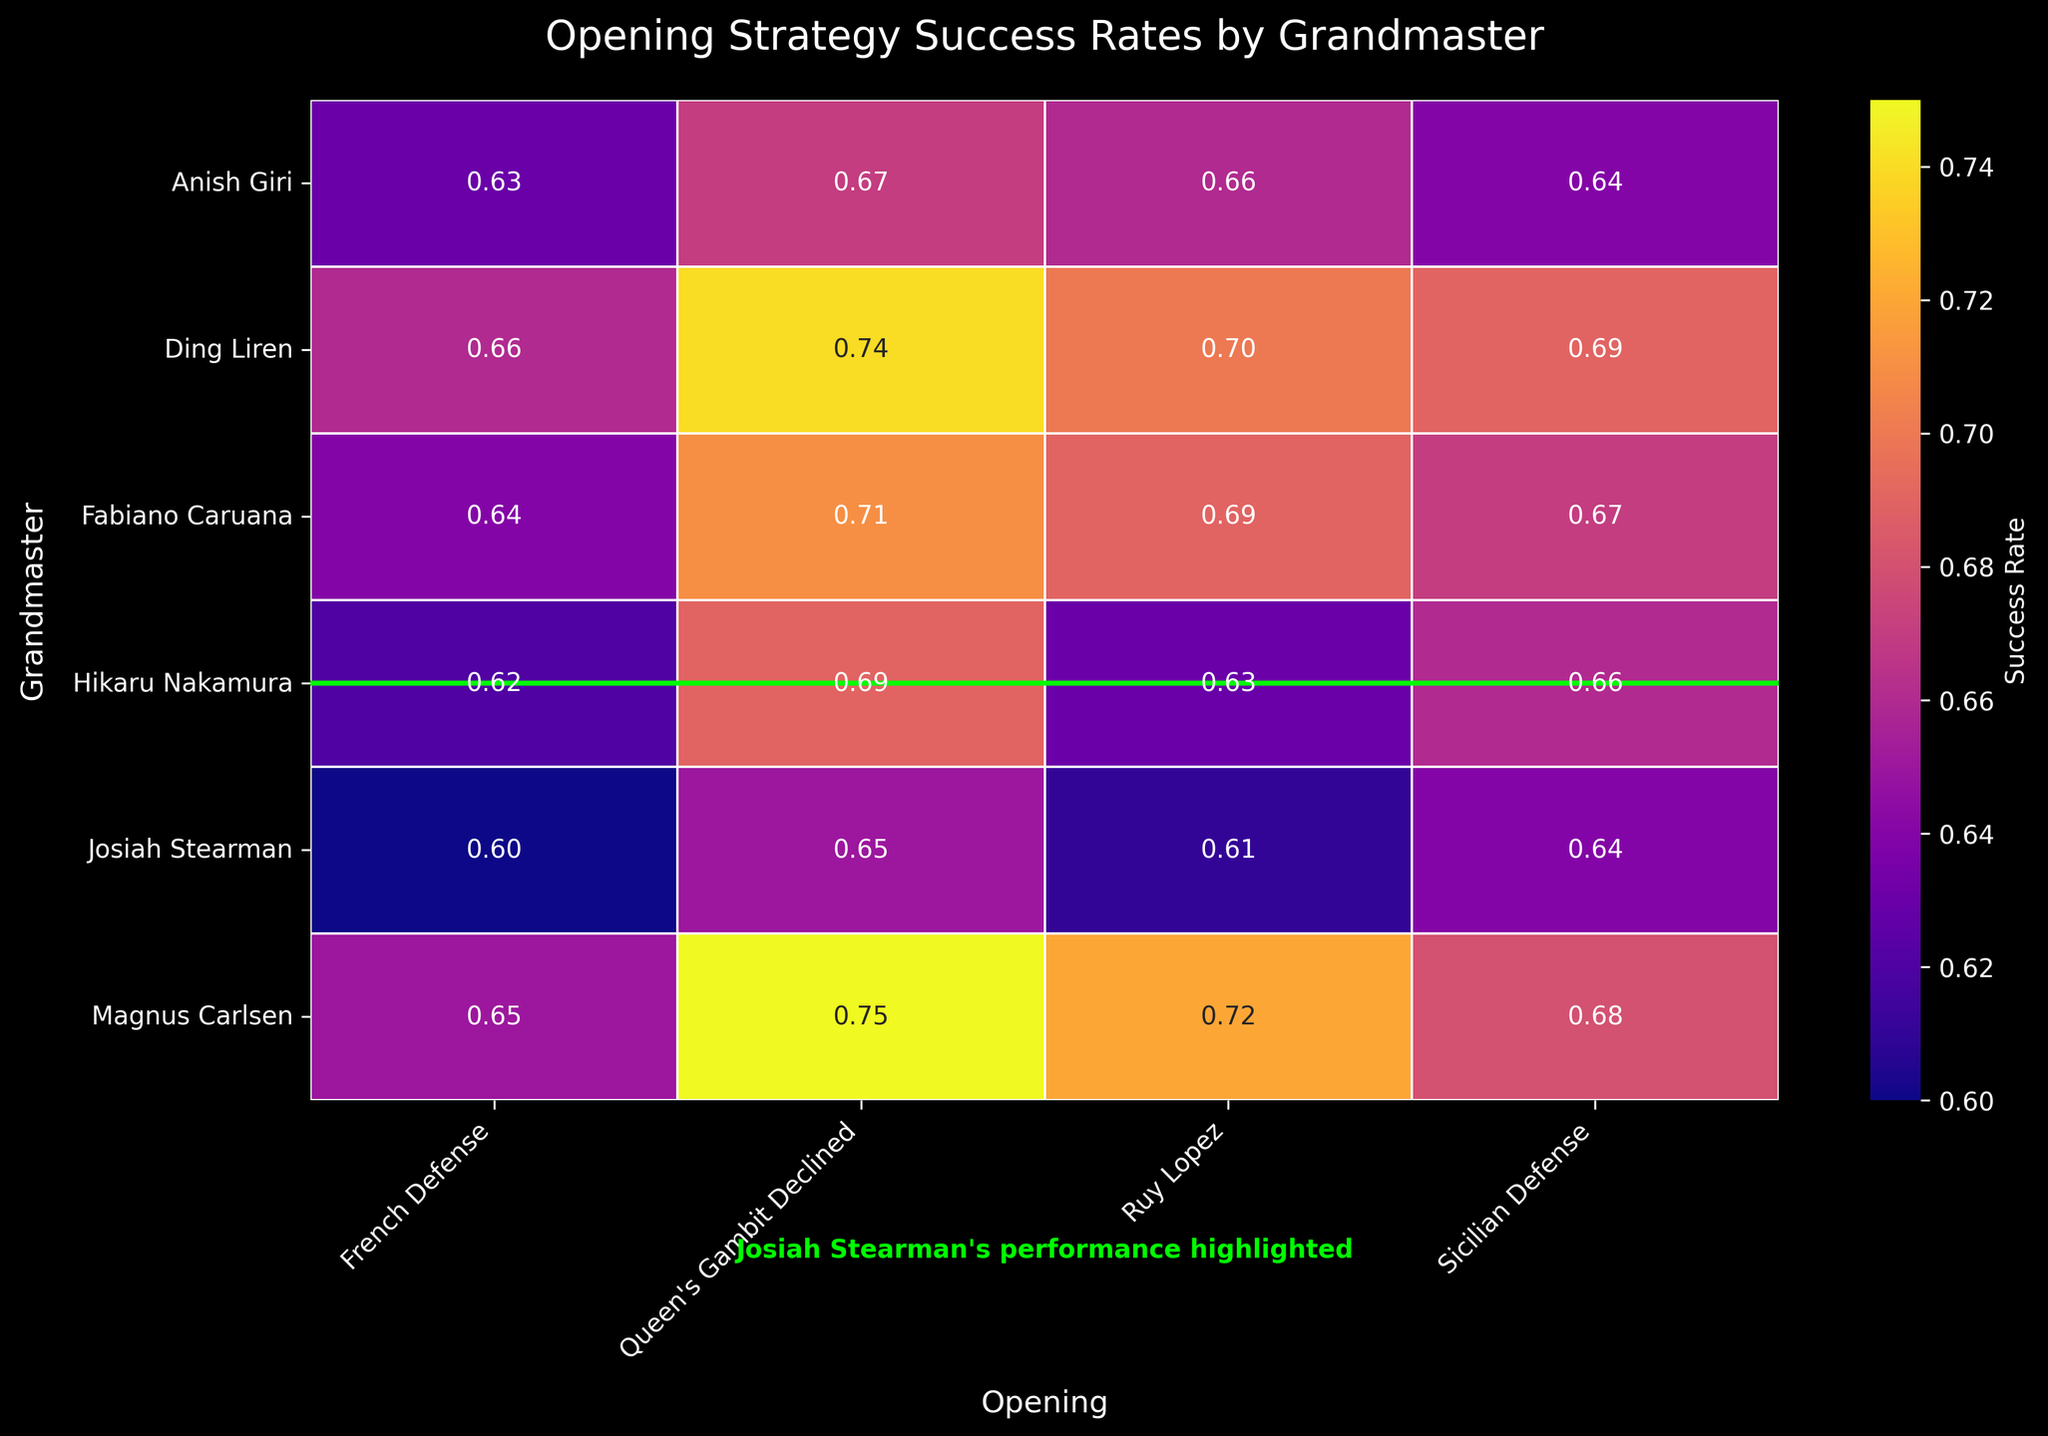What is the title of the heatmap? The title is usually displayed at the top of the plot. It is a descriptor for the figure and can be directly read from the top part of the figure.
Answer: Opening Strategy Success Rates by Grandmaster Which grandmaster has the highest success rate with the Ruy Lopez opening? Locate the column for the Ruy Lopez opening on the heatmap. Then, identify the row with the highest value in the same column. The corresponding grandmaster name in that row will be the answer.
Answer: Magnus Carlsen Compare the success rates of Josiah Stearman and Hikaru Nakamura in the Sicilian Defense opening. Who performs better? Look at the values in the Sicilian Defense column for both Josiah Stearman and Hikaru Nakamura. Compare the numbers directly. Josiah Stearman has a success rate of 0.64, and Hikaru Nakamura has 0.66.
Answer: Hikaru Nakamura What is the average success rate of Fabiano Caruana across all openings? Find all the success rates for Fabiano Caruana in the heatmap. Sum these values and then divide by the number of openings to get the average. The values are 0.69, 0.67, 0.71, 0.64. The average is (0.69 + 0.67 + 0.71 + 0.64) / 4 = 0.6775.
Answer: 0.68 Is there any grandmaster with a perfect balance of success rates (same values) across all openings? Check the heatmap rows for each grandmaster to see if all the values in a row are the same, indicating a balanced success rate across openings.
Answer: No How does the success rate of Josiah Stearman in the Queen's Gambit Declined compare to Ding Liren in the same opening? Locate the Queen's Gambit Declined column and compare the success rates for Josiah Stearman (0.65) and Ding Liren (0.74). Since 0.74 is greater than 0.65, Ding Liren performs better.
Answer: Ding Liren Which opening does Anish Giri perform best in? For Anish Giri, find the highest success rate across all columns and note the corresponding opening. The highest value is 0.67 in the Queen’s Gambit Declined opening.
Answer: Queen's Gambit Declined In which opening does Josiah Stearman have the least success? Find the smallest value in the row corresponding to Josiah Stearman, identifying the opening associated with this value. The lowest success rate is 0.60 in the French Defense.
Answer: French Defense 